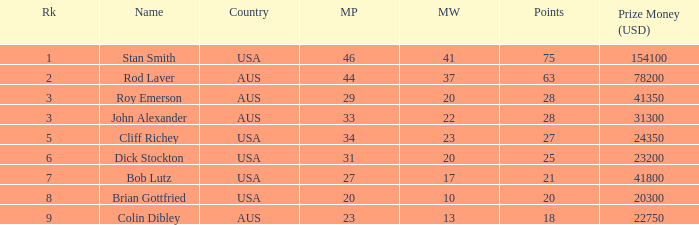How many countries had 21 points 1.0. 